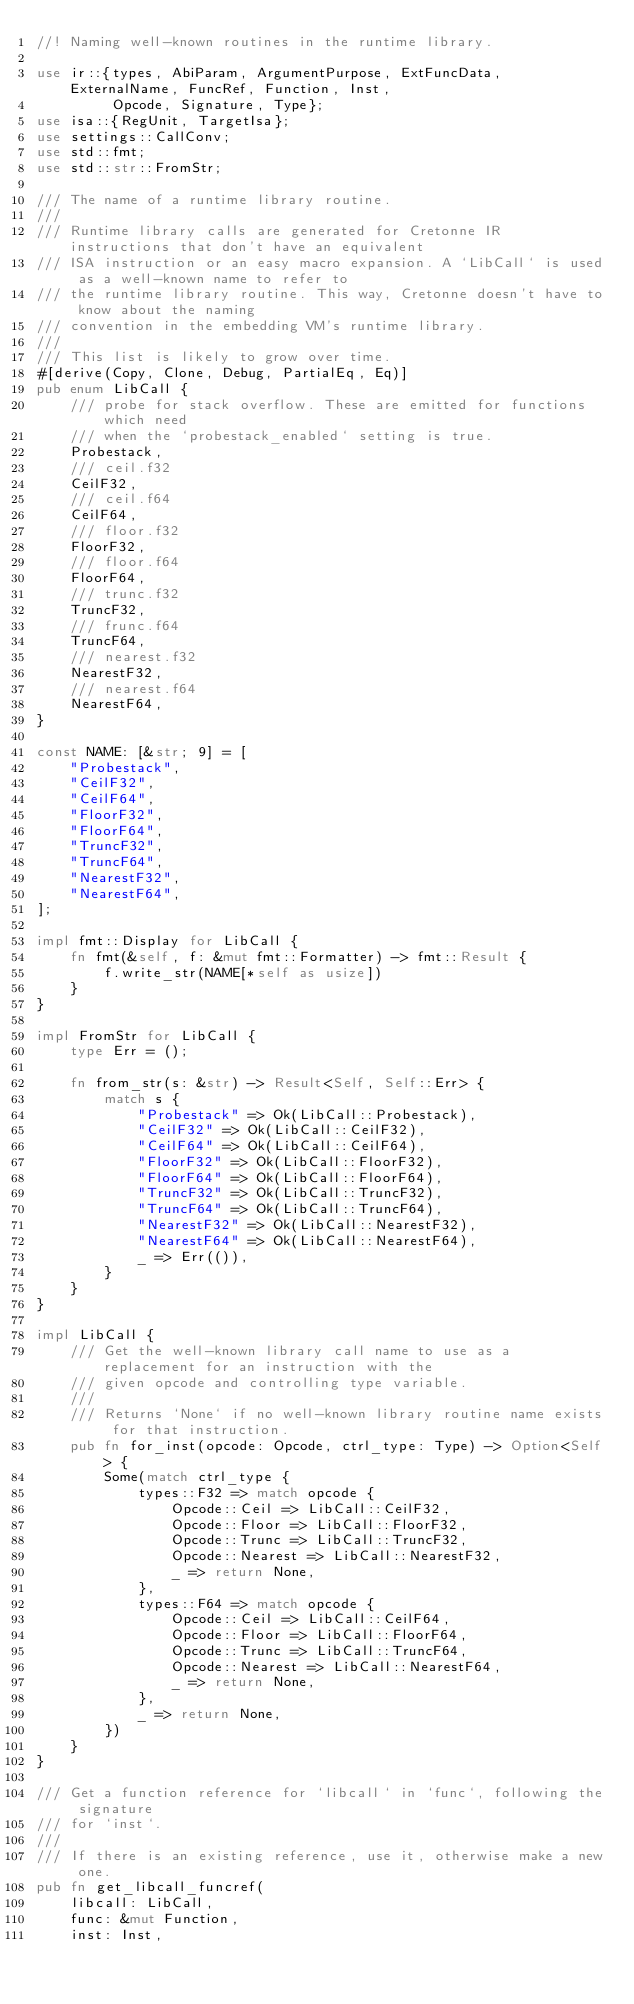Convert code to text. <code><loc_0><loc_0><loc_500><loc_500><_Rust_>//! Naming well-known routines in the runtime library.

use ir::{types, AbiParam, ArgumentPurpose, ExtFuncData, ExternalName, FuncRef, Function, Inst,
         Opcode, Signature, Type};
use isa::{RegUnit, TargetIsa};
use settings::CallConv;
use std::fmt;
use std::str::FromStr;

/// The name of a runtime library routine.
///
/// Runtime library calls are generated for Cretonne IR instructions that don't have an equivalent
/// ISA instruction or an easy macro expansion. A `LibCall` is used as a well-known name to refer to
/// the runtime library routine. This way, Cretonne doesn't have to know about the naming
/// convention in the embedding VM's runtime library.
///
/// This list is likely to grow over time.
#[derive(Copy, Clone, Debug, PartialEq, Eq)]
pub enum LibCall {
    /// probe for stack overflow. These are emitted for functions which need
    /// when the `probestack_enabled` setting is true.
    Probestack,
    /// ceil.f32
    CeilF32,
    /// ceil.f64
    CeilF64,
    /// floor.f32
    FloorF32,
    /// floor.f64
    FloorF64,
    /// trunc.f32
    TruncF32,
    /// frunc.f64
    TruncF64,
    /// nearest.f32
    NearestF32,
    /// nearest.f64
    NearestF64,
}

const NAME: [&str; 9] = [
    "Probestack",
    "CeilF32",
    "CeilF64",
    "FloorF32",
    "FloorF64",
    "TruncF32",
    "TruncF64",
    "NearestF32",
    "NearestF64",
];

impl fmt::Display for LibCall {
    fn fmt(&self, f: &mut fmt::Formatter) -> fmt::Result {
        f.write_str(NAME[*self as usize])
    }
}

impl FromStr for LibCall {
    type Err = ();

    fn from_str(s: &str) -> Result<Self, Self::Err> {
        match s {
            "Probestack" => Ok(LibCall::Probestack),
            "CeilF32" => Ok(LibCall::CeilF32),
            "CeilF64" => Ok(LibCall::CeilF64),
            "FloorF32" => Ok(LibCall::FloorF32),
            "FloorF64" => Ok(LibCall::FloorF64),
            "TruncF32" => Ok(LibCall::TruncF32),
            "TruncF64" => Ok(LibCall::TruncF64),
            "NearestF32" => Ok(LibCall::NearestF32),
            "NearestF64" => Ok(LibCall::NearestF64),
            _ => Err(()),
        }
    }
}

impl LibCall {
    /// Get the well-known library call name to use as a replacement for an instruction with the
    /// given opcode and controlling type variable.
    ///
    /// Returns `None` if no well-known library routine name exists for that instruction.
    pub fn for_inst(opcode: Opcode, ctrl_type: Type) -> Option<Self> {
        Some(match ctrl_type {
            types::F32 => match opcode {
                Opcode::Ceil => LibCall::CeilF32,
                Opcode::Floor => LibCall::FloorF32,
                Opcode::Trunc => LibCall::TruncF32,
                Opcode::Nearest => LibCall::NearestF32,
                _ => return None,
            },
            types::F64 => match opcode {
                Opcode::Ceil => LibCall::CeilF64,
                Opcode::Floor => LibCall::FloorF64,
                Opcode::Trunc => LibCall::TruncF64,
                Opcode::Nearest => LibCall::NearestF64,
                _ => return None,
            },
            _ => return None,
        })
    }
}

/// Get a function reference for `libcall` in `func`, following the signature
/// for `inst`.
///
/// If there is an existing reference, use it, otherwise make a new one.
pub fn get_libcall_funcref(
    libcall: LibCall,
    func: &mut Function,
    inst: Inst,</code> 